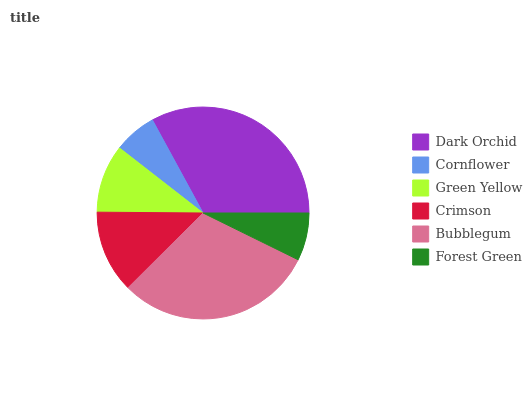Is Cornflower the minimum?
Answer yes or no. Yes. Is Dark Orchid the maximum?
Answer yes or no. Yes. Is Green Yellow the minimum?
Answer yes or no. No. Is Green Yellow the maximum?
Answer yes or no. No. Is Green Yellow greater than Cornflower?
Answer yes or no. Yes. Is Cornflower less than Green Yellow?
Answer yes or no. Yes. Is Cornflower greater than Green Yellow?
Answer yes or no. No. Is Green Yellow less than Cornflower?
Answer yes or no. No. Is Crimson the high median?
Answer yes or no. Yes. Is Green Yellow the low median?
Answer yes or no. Yes. Is Forest Green the high median?
Answer yes or no. No. Is Crimson the low median?
Answer yes or no. No. 